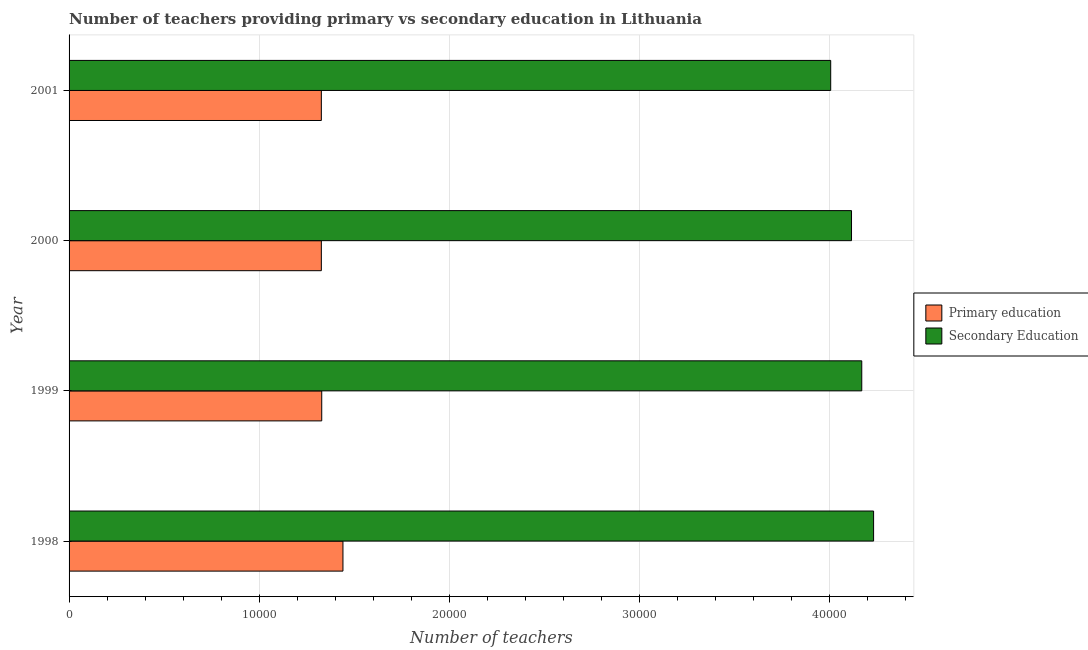How many groups of bars are there?
Offer a very short reply. 4. How many bars are there on the 2nd tick from the top?
Ensure brevity in your answer.  2. What is the number of secondary teachers in 1998?
Ensure brevity in your answer.  4.23e+04. Across all years, what is the maximum number of secondary teachers?
Your response must be concise. 4.23e+04. Across all years, what is the minimum number of secondary teachers?
Your answer should be compact. 4.00e+04. What is the total number of secondary teachers in the graph?
Provide a succinct answer. 1.65e+05. What is the difference between the number of primary teachers in 1998 and that in 1999?
Offer a very short reply. 1116. What is the difference between the number of primary teachers in 2000 and the number of secondary teachers in 1998?
Ensure brevity in your answer.  -2.90e+04. What is the average number of primary teachers per year?
Offer a very short reply. 1.36e+04. In the year 2001, what is the difference between the number of primary teachers and number of secondary teachers?
Provide a succinct answer. -2.68e+04. In how many years, is the number of primary teachers greater than 42000 ?
Ensure brevity in your answer.  0. What is the ratio of the number of secondary teachers in 2000 to that in 2001?
Ensure brevity in your answer.  1.03. Is the difference between the number of secondary teachers in 2000 and 2001 greater than the difference between the number of primary teachers in 2000 and 2001?
Provide a short and direct response. Yes. What is the difference between the highest and the second highest number of primary teachers?
Keep it short and to the point. 1116. What is the difference between the highest and the lowest number of secondary teachers?
Your response must be concise. 2255. Is the sum of the number of primary teachers in 1999 and 2001 greater than the maximum number of secondary teachers across all years?
Keep it short and to the point. No. What does the 1st bar from the bottom in 1998 represents?
Your answer should be compact. Primary education. Are all the bars in the graph horizontal?
Provide a short and direct response. Yes. What is the difference between two consecutive major ticks on the X-axis?
Provide a succinct answer. 10000. Are the values on the major ticks of X-axis written in scientific E-notation?
Offer a very short reply. No. Does the graph contain any zero values?
Your response must be concise. No. Where does the legend appear in the graph?
Give a very brief answer. Center right. How many legend labels are there?
Provide a short and direct response. 2. What is the title of the graph?
Offer a very short reply. Number of teachers providing primary vs secondary education in Lithuania. Does "Exports" appear as one of the legend labels in the graph?
Offer a terse response. No. What is the label or title of the X-axis?
Offer a terse response. Number of teachers. What is the label or title of the Y-axis?
Provide a succinct answer. Year. What is the Number of teachers in Primary education in 1998?
Give a very brief answer. 1.44e+04. What is the Number of teachers in Secondary Education in 1998?
Offer a terse response. 4.23e+04. What is the Number of teachers of Primary education in 1999?
Your response must be concise. 1.33e+04. What is the Number of teachers of Secondary Education in 1999?
Provide a short and direct response. 4.17e+04. What is the Number of teachers in Primary education in 2000?
Ensure brevity in your answer.  1.33e+04. What is the Number of teachers of Secondary Education in 2000?
Make the answer very short. 4.11e+04. What is the Number of teachers of Primary education in 2001?
Provide a succinct answer. 1.33e+04. What is the Number of teachers in Secondary Education in 2001?
Provide a succinct answer. 4.00e+04. Across all years, what is the maximum Number of teachers in Primary education?
Make the answer very short. 1.44e+04. Across all years, what is the maximum Number of teachers in Secondary Education?
Give a very brief answer. 4.23e+04. Across all years, what is the minimum Number of teachers of Primary education?
Your answer should be very brief. 1.33e+04. Across all years, what is the minimum Number of teachers of Secondary Education?
Offer a very short reply. 4.00e+04. What is the total Number of teachers of Primary education in the graph?
Provide a short and direct response. 5.42e+04. What is the total Number of teachers of Secondary Education in the graph?
Offer a very short reply. 1.65e+05. What is the difference between the Number of teachers in Primary education in 1998 and that in 1999?
Provide a succinct answer. 1116. What is the difference between the Number of teachers in Secondary Education in 1998 and that in 1999?
Offer a terse response. 622. What is the difference between the Number of teachers of Primary education in 1998 and that in 2000?
Provide a succinct answer. 1136. What is the difference between the Number of teachers of Secondary Education in 1998 and that in 2000?
Keep it short and to the point. 1161. What is the difference between the Number of teachers in Primary education in 1998 and that in 2001?
Make the answer very short. 1136. What is the difference between the Number of teachers of Secondary Education in 1998 and that in 2001?
Provide a short and direct response. 2255. What is the difference between the Number of teachers in Secondary Education in 1999 and that in 2000?
Your answer should be compact. 539. What is the difference between the Number of teachers in Secondary Education in 1999 and that in 2001?
Give a very brief answer. 1633. What is the difference between the Number of teachers in Primary education in 2000 and that in 2001?
Your answer should be compact. 0. What is the difference between the Number of teachers in Secondary Education in 2000 and that in 2001?
Make the answer very short. 1094. What is the difference between the Number of teachers of Primary education in 1998 and the Number of teachers of Secondary Education in 1999?
Ensure brevity in your answer.  -2.73e+04. What is the difference between the Number of teachers in Primary education in 1998 and the Number of teachers in Secondary Education in 2000?
Offer a very short reply. -2.67e+04. What is the difference between the Number of teachers in Primary education in 1998 and the Number of teachers in Secondary Education in 2001?
Ensure brevity in your answer.  -2.56e+04. What is the difference between the Number of teachers in Primary education in 1999 and the Number of teachers in Secondary Education in 2000?
Your answer should be very brief. -2.79e+04. What is the difference between the Number of teachers of Primary education in 1999 and the Number of teachers of Secondary Education in 2001?
Offer a very short reply. -2.68e+04. What is the difference between the Number of teachers of Primary education in 2000 and the Number of teachers of Secondary Education in 2001?
Your response must be concise. -2.68e+04. What is the average Number of teachers in Primary education per year?
Keep it short and to the point. 1.36e+04. What is the average Number of teachers in Secondary Education per year?
Offer a very short reply. 4.13e+04. In the year 1998, what is the difference between the Number of teachers in Primary education and Number of teachers in Secondary Education?
Make the answer very short. -2.79e+04. In the year 1999, what is the difference between the Number of teachers of Primary education and Number of teachers of Secondary Education?
Make the answer very short. -2.84e+04. In the year 2000, what is the difference between the Number of teachers of Primary education and Number of teachers of Secondary Education?
Your answer should be very brief. -2.79e+04. In the year 2001, what is the difference between the Number of teachers in Primary education and Number of teachers in Secondary Education?
Offer a terse response. -2.68e+04. What is the ratio of the Number of teachers of Primary education in 1998 to that in 1999?
Keep it short and to the point. 1.08. What is the ratio of the Number of teachers of Secondary Education in 1998 to that in 1999?
Your answer should be compact. 1.01. What is the ratio of the Number of teachers in Primary education in 1998 to that in 2000?
Give a very brief answer. 1.09. What is the ratio of the Number of teachers of Secondary Education in 1998 to that in 2000?
Give a very brief answer. 1.03. What is the ratio of the Number of teachers in Primary education in 1998 to that in 2001?
Make the answer very short. 1.09. What is the ratio of the Number of teachers of Secondary Education in 1998 to that in 2001?
Your answer should be very brief. 1.06. What is the ratio of the Number of teachers in Primary education in 1999 to that in 2000?
Your answer should be compact. 1. What is the ratio of the Number of teachers in Secondary Education in 1999 to that in 2000?
Your answer should be compact. 1.01. What is the ratio of the Number of teachers in Secondary Education in 1999 to that in 2001?
Offer a terse response. 1.04. What is the ratio of the Number of teachers in Secondary Education in 2000 to that in 2001?
Keep it short and to the point. 1.03. What is the difference between the highest and the second highest Number of teachers of Primary education?
Offer a very short reply. 1116. What is the difference between the highest and the second highest Number of teachers in Secondary Education?
Your response must be concise. 622. What is the difference between the highest and the lowest Number of teachers of Primary education?
Your answer should be very brief. 1136. What is the difference between the highest and the lowest Number of teachers of Secondary Education?
Provide a succinct answer. 2255. 